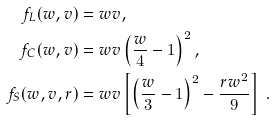<formula> <loc_0><loc_0><loc_500><loc_500>f _ { L } ( w , v ) & = w v , \\ f _ { C } ( w , v ) & = w v \left ( \frac { w } { 4 } - 1 \right ) ^ { 2 } , \\ f _ { S } ( w , v , r ) & = w v \left [ \left ( \frac { w } { 3 } - 1 \right ) ^ { 2 } - \frac { r w ^ { 2 } } { 9 } \right ] \ .</formula> 